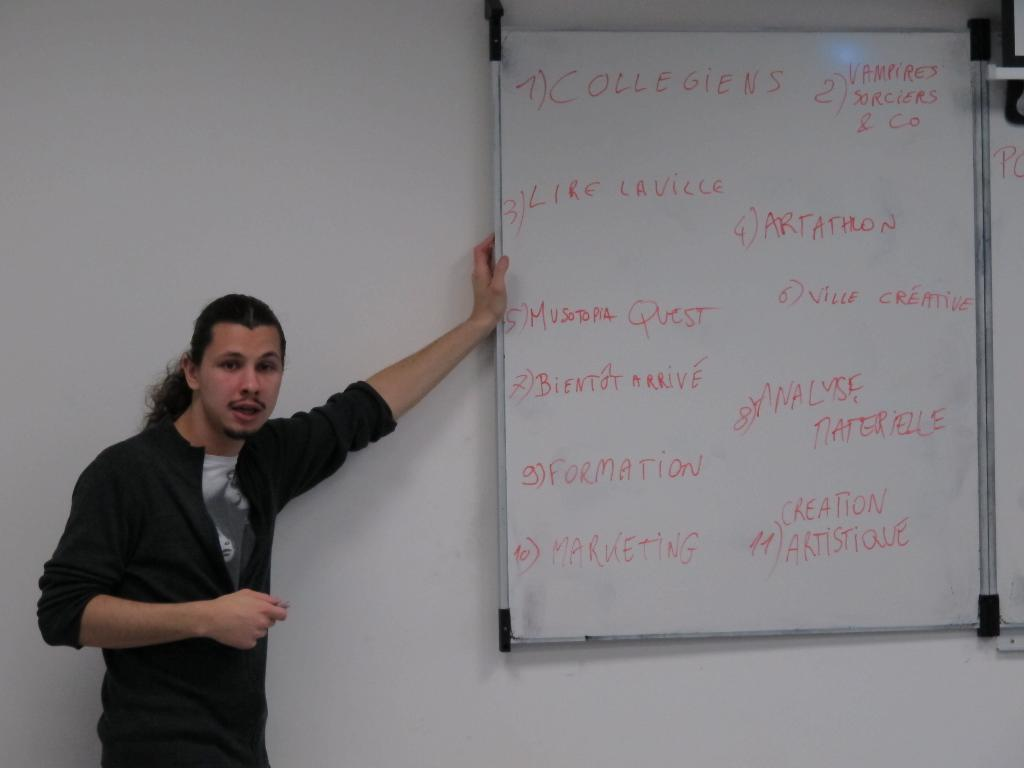<image>
Share a concise interpretation of the image provided. A person standing next to a whiteboard with Collegiens written on it. 